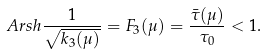Convert formula to latex. <formula><loc_0><loc_0><loc_500><loc_500>A r s h \frac { 1 } { \sqrt { k _ { 3 } ( \mu ) } } = { F } _ { 3 } ( \mu ) = \frac { \bar { \tau } ( \mu ) } { \tau _ { 0 } } < 1 .</formula> 